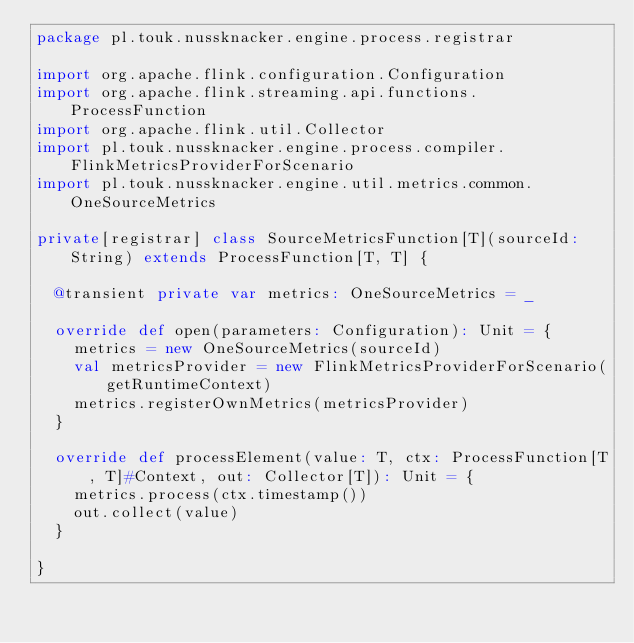Convert code to text. <code><loc_0><loc_0><loc_500><loc_500><_Scala_>package pl.touk.nussknacker.engine.process.registrar

import org.apache.flink.configuration.Configuration
import org.apache.flink.streaming.api.functions.ProcessFunction
import org.apache.flink.util.Collector
import pl.touk.nussknacker.engine.process.compiler.FlinkMetricsProviderForScenario
import pl.touk.nussknacker.engine.util.metrics.common.OneSourceMetrics

private[registrar] class SourceMetricsFunction[T](sourceId: String) extends ProcessFunction[T, T] {

  @transient private var metrics: OneSourceMetrics = _

  override def open(parameters: Configuration): Unit = {
    metrics = new OneSourceMetrics(sourceId)
    val metricsProvider = new FlinkMetricsProviderForScenario(getRuntimeContext)
    metrics.registerOwnMetrics(metricsProvider)
  }

  override def processElement(value: T, ctx: ProcessFunction[T, T]#Context, out: Collector[T]): Unit = {
    metrics.process(ctx.timestamp())
    out.collect(value)
  }

}
</code> 